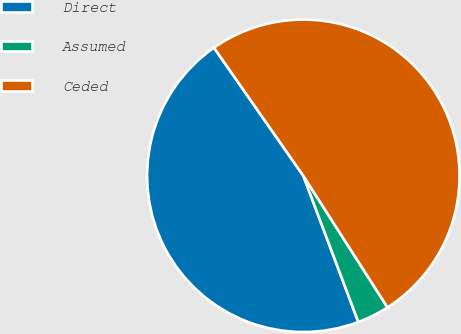Convert chart. <chart><loc_0><loc_0><loc_500><loc_500><pie_chart><fcel>Direct<fcel>Assumed<fcel>Ceded<nl><fcel>46.03%<fcel>3.33%<fcel>50.63%<nl></chart> 